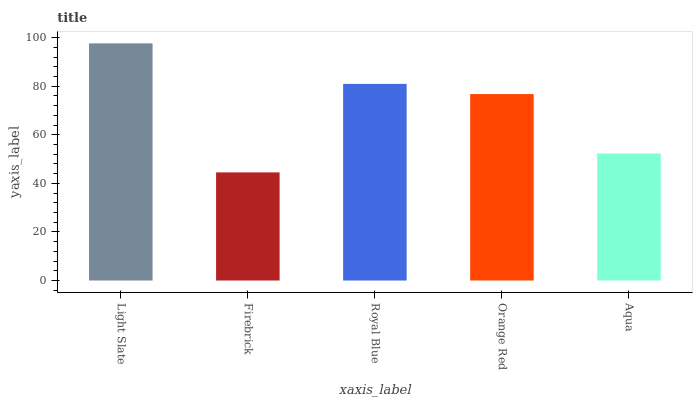Is Firebrick the minimum?
Answer yes or no. Yes. Is Light Slate the maximum?
Answer yes or no. Yes. Is Royal Blue the minimum?
Answer yes or no. No. Is Royal Blue the maximum?
Answer yes or no. No. Is Royal Blue greater than Firebrick?
Answer yes or no. Yes. Is Firebrick less than Royal Blue?
Answer yes or no. Yes. Is Firebrick greater than Royal Blue?
Answer yes or no. No. Is Royal Blue less than Firebrick?
Answer yes or no. No. Is Orange Red the high median?
Answer yes or no. Yes. Is Orange Red the low median?
Answer yes or no. Yes. Is Royal Blue the high median?
Answer yes or no. No. Is Aqua the low median?
Answer yes or no. No. 